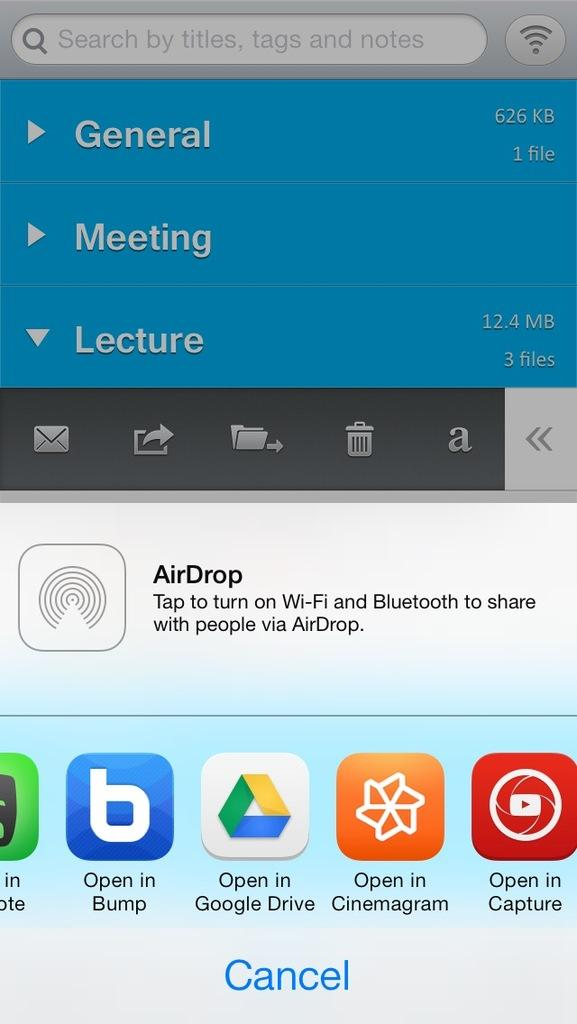<image>
Render a clear and concise summary of the photo. the screen of an iphone trying to send a copy of something to someone, including by airdrop 